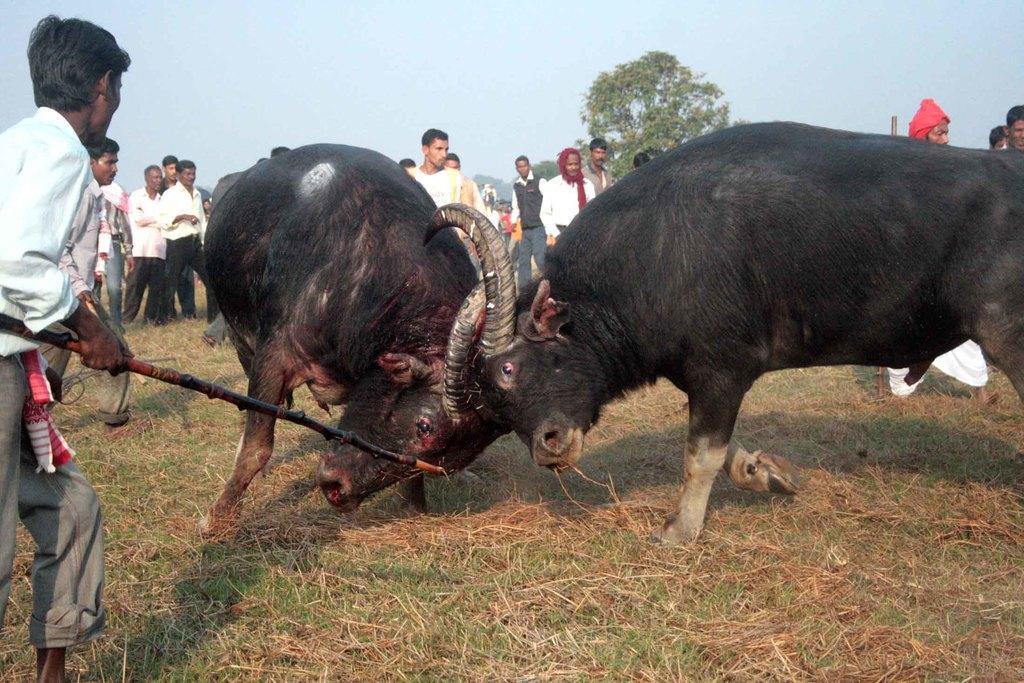Please provide a concise description of this image. In this image there are two bulls fighting, a person standing and holding a stick , and in the background there are group of people , trees,sky. 